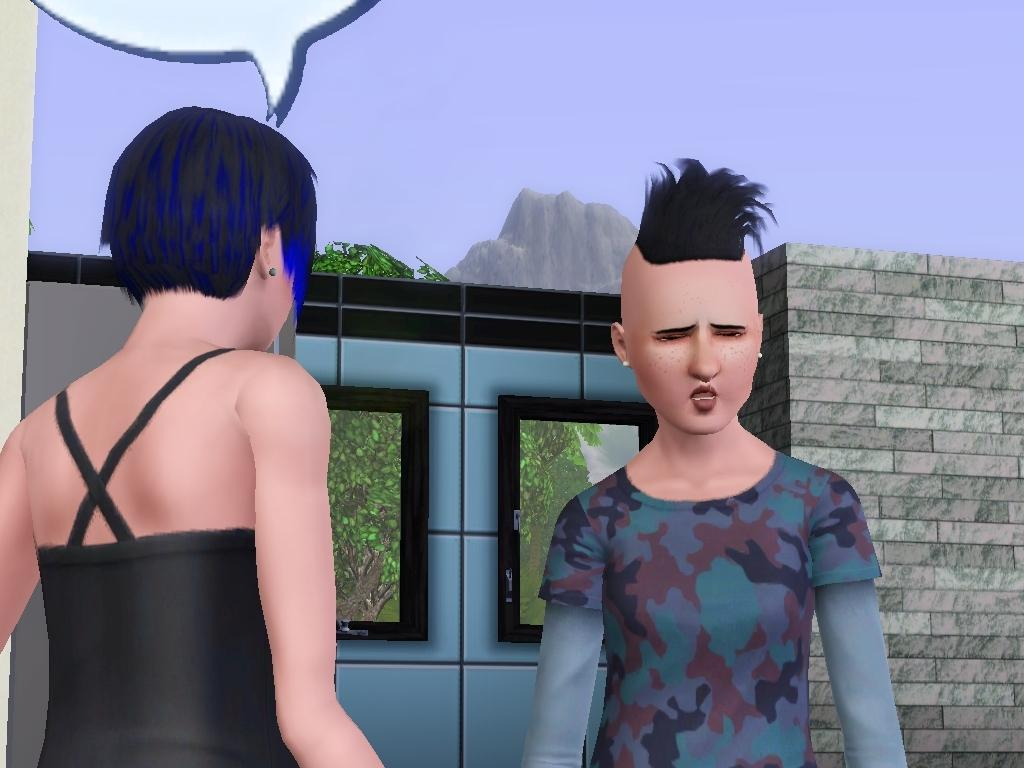How many people are present in the image? There are two people in the image. What is located behind the people in the image? There is a wall in the image. What can be seen on the wall in the image? There are windows in the image. What type of natural scenery is visible in the image? There are trees and a mountain in the image. What is visible in the background of the image? The sky is visible in the background of the image. What is the topic of the heated discussion taking place on the floor in the image? There is no heated discussion taking place on the floor in the image; it only shows two people, a wall, windows, trees, a mountain, and the sky. 